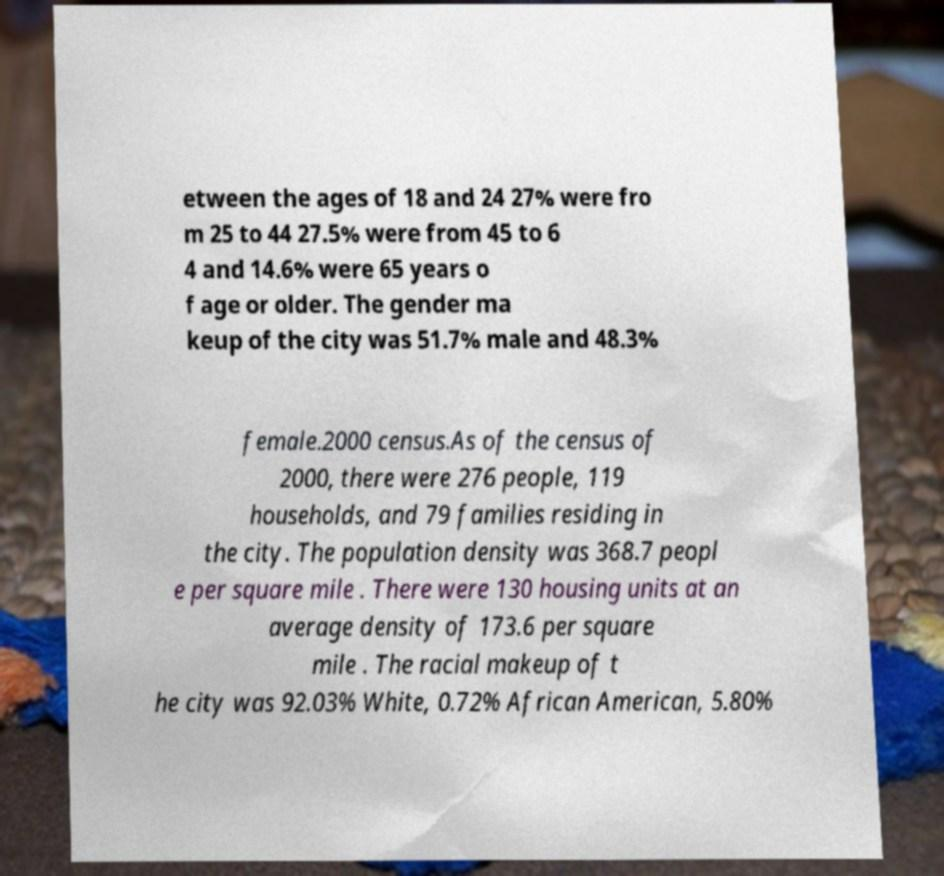Please read and relay the text visible in this image. What does it say? etween the ages of 18 and 24 27% were fro m 25 to 44 27.5% were from 45 to 6 4 and 14.6% were 65 years o f age or older. The gender ma keup of the city was 51.7% male and 48.3% female.2000 census.As of the census of 2000, there were 276 people, 119 households, and 79 families residing in the city. The population density was 368.7 peopl e per square mile . There were 130 housing units at an average density of 173.6 per square mile . The racial makeup of t he city was 92.03% White, 0.72% African American, 5.80% 